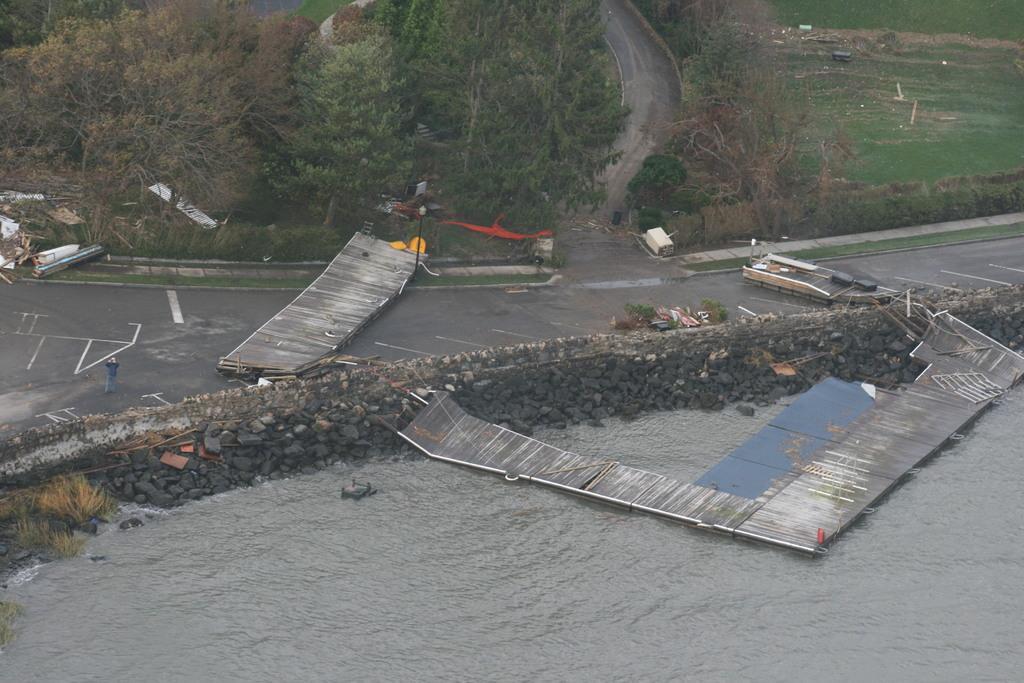Could you give a brief overview of what you see in this image? In this image I can see the water, a wooden bridge on the surface of the water, the road, a person standing and few other objects. In the background I can see few trees and some grass. 